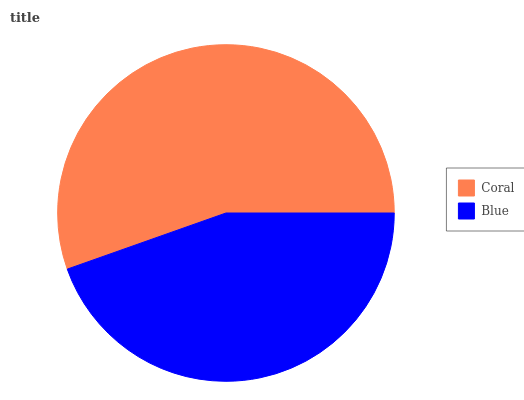Is Blue the minimum?
Answer yes or no. Yes. Is Coral the maximum?
Answer yes or no. Yes. Is Blue the maximum?
Answer yes or no. No. Is Coral greater than Blue?
Answer yes or no. Yes. Is Blue less than Coral?
Answer yes or no. Yes. Is Blue greater than Coral?
Answer yes or no. No. Is Coral less than Blue?
Answer yes or no. No. Is Coral the high median?
Answer yes or no. Yes. Is Blue the low median?
Answer yes or no. Yes. Is Blue the high median?
Answer yes or no. No. Is Coral the low median?
Answer yes or no. No. 